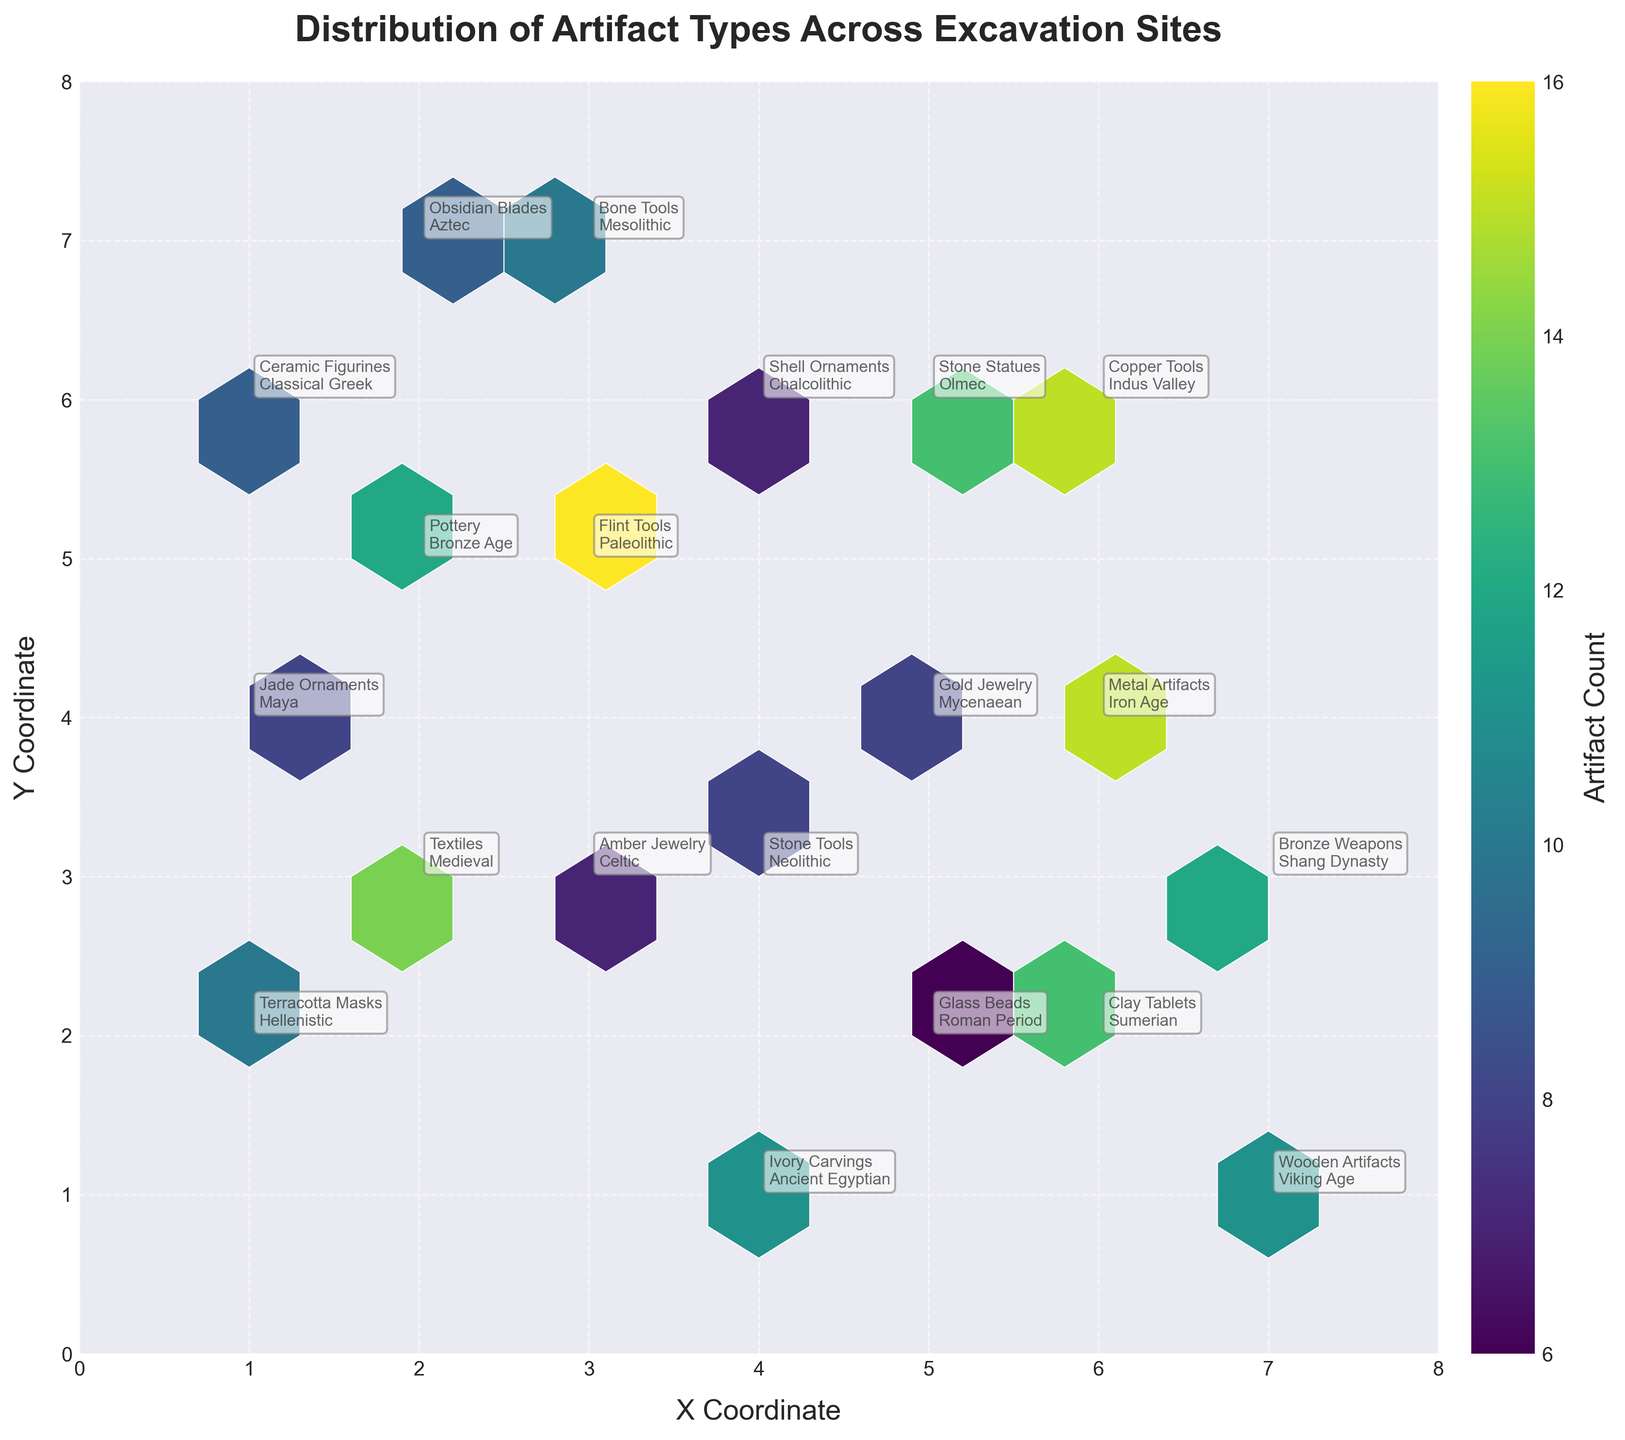what is the title of the plot? The title is at the top of the figure, typically in bold font and larger size. Here, it is clearly written above the rest of the content.
Answer: Distribution of Artifact Types Across Excavation Sites how many artifact types are represented in the plot? Each type of artifact is labeled by annotations, visible near the points in the hexbin. Count the unique labels to get the answer.
Answer: 20 which artifact type has the highest count? By observing the color intensity in the hexbin plot, the area with the darkest shade, representing the highest count, can be identified.
Answer: Flint Tools between Stone Tools and Shell Ornaments, which has a higher count? Locate both artifact types on the plot and compare the color intensity or annotated counts.
Answer: Shell Ornaments how many time periods are represented in the plot? Each annotation includes the time period of the artifact. Count the distinct time periods listed.
Answer: 20 what is the x and y coordinate of Jade Ornaments? Look for the annotation of Jade Ornaments and note its position on the x and y axis.
Answer: (1, 4) which artifact type is found at the coordinates (4, 1)? Identify the annotation positioned at (4, 1) to determine which artifact is represented there.
Answer: Ivory Carvings what is the average count of artifacts at coordinates (3, 3) and (4, 3)? Locate the counts for artifacts at (3, 3) and (4, 3), sum them up, and divide by 2. (7 + 8) / 2 = 7.5.
Answer: 7.5 which artifact type from the Bronze Age is present in the plot? Look through the annotations for the Bronze Age label to find the corresponding artifact type.
Answer: Pottery what is the approximate range of coordinates displayed in the plot? The x and y axes limits define this range. Check the min and max values set on both axes.
Answer: 0 to 8 